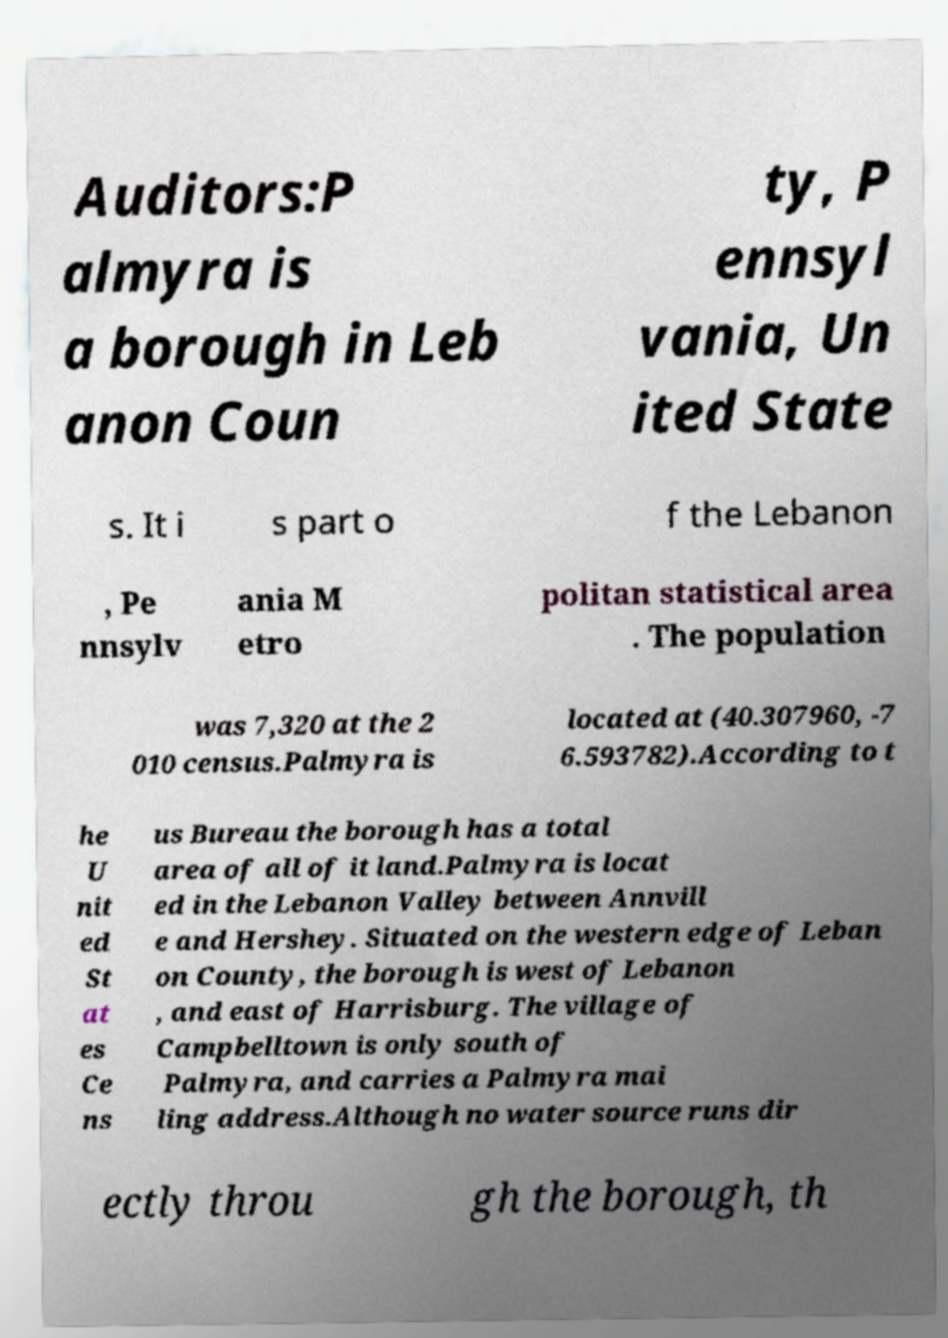Please identify and transcribe the text found in this image. Auditors:P almyra is a borough in Leb anon Coun ty, P ennsyl vania, Un ited State s. It i s part o f the Lebanon , Pe nnsylv ania M etro politan statistical area . The population was 7,320 at the 2 010 census.Palmyra is located at (40.307960, -7 6.593782).According to t he U nit ed St at es Ce ns us Bureau the borough has a total area of all of it land.Palmyra is locat ed in the Lebanon Valley between Annvill e and Hershey. Situated on the western edge of Leban on County, the borough is west of Lebanon , and east of Harrisburg. The village of Campbelltown is only south of Palmyra, and carries a Palmyra mai ling address.Although no water source runs dir ectly throu gh the borough, th 